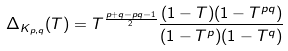<formula> <loc_0><loc_0><loc_500><loc_500>\Delta _ { K _ { p , q } } ( T ) = T ^ { \frac { p + q - p q - 1 } { 2 } } \frac { ( 1 - T ) ( 1 - T ^ { p q } ) } { ( 1 - T ^ { p } ) ( 1 - T ^ { q } ) }</formula> 